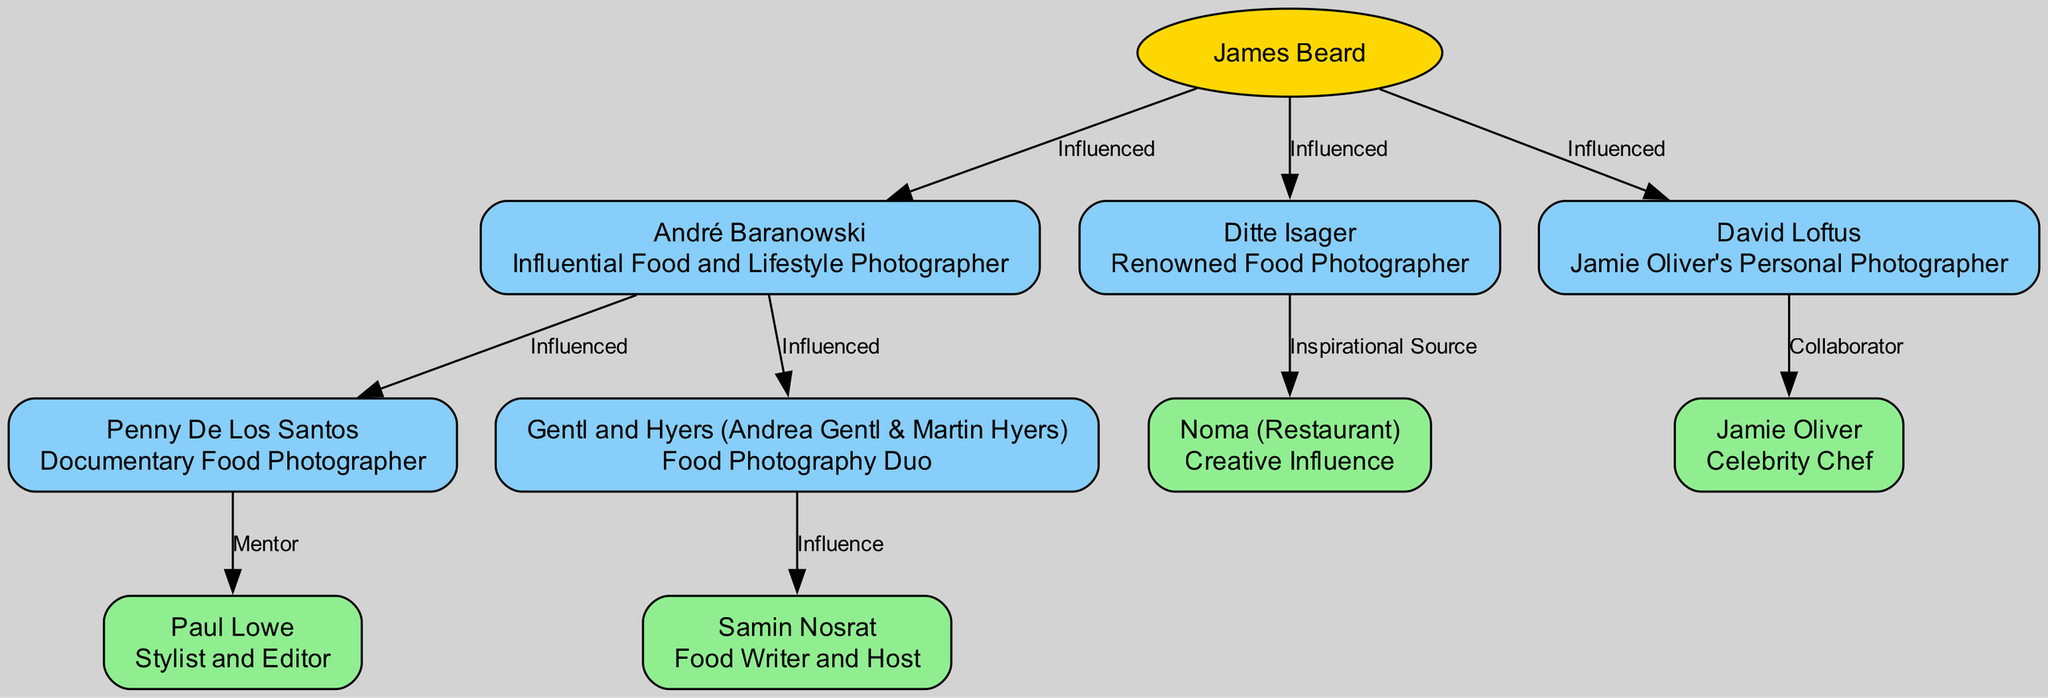What's the role of James Beard? James Beard is listed at the top of the diagram as the "Pioneering Culinary Photographer." This information is directly taken from the node representing him in the family tree.
Answer: Pioneering Culinary Photographer How many children does André Baranowski have? Looking at the diagram, André Baranowski has two children: Penny De Los Santos and Gentl and Hyers. This is derived from the connections shown in his node.
Answer: 2 Who is the mentor of Penny De Los Santos? The diagram indicates that Paul Lowe is the mentor of Penny De Los Santos through a direct relationship line connecting them. This specific relationship is mentioned under Penny’s node.
Answer: Paul Lowe What is the role of Samin Nosrat? Samin Nosrat is described in the diagram as a "Food Writer and Host," which is stated in the node representing her.
Answer: Food Writer and Host How is David Loftus connected to Jamie Oliver? The diagram shows a direct line connecting David Loftus to Jamie Oliver, indicating a "Collaborator" relationship between them. This analysis draws from the relationship label on the connecting edge.
Answer: Collaborator Which restaurant is considered a creative influence for Ditte Isager? Noma is identified as a "Creative Influence" for Ditte Isager in the diagram, as indicated in the node linked under her.
Answer: Noma Who are Gentl and Hyers? Gentl and Hyers are a "Food Photography Duo," as specified in the role section of their node within the diagram.
Answer: Food Photography Duo How many influential individuals are listed under James Beard? The diagram indicates that there are three influential individuals listed as children under James Beard: André Baranowski, Ditte Isager, and David Loftus. Therefore, we obtain the count by assessing the number of child nodes stemming from the root.
Answer: 3 What relationship does André Baranowski have with Paul Lowe? In the diagram, Paul Lowe is indicated as a "Mentor" to Penny De Los Santos, who is directly under André Baranowski, suggesting an indirect mentorship pathway. Thus, the relationship can be inferred indirectly rather than directly stated.
Answer: Indirectly related 